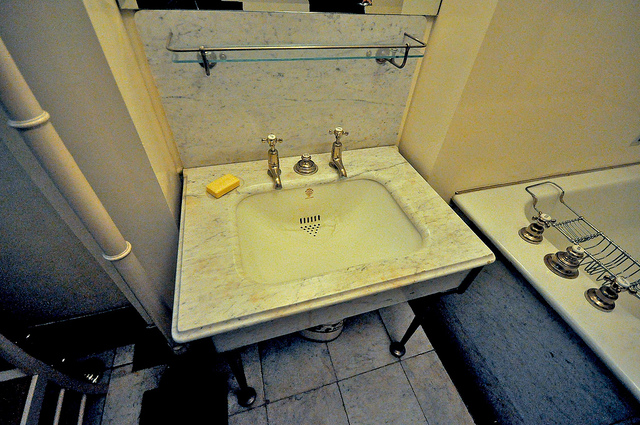What seems to be the material of the sink's countertop? The sink's countertop appears to be made of marble, characterized by its smooth texture and natural veining. 